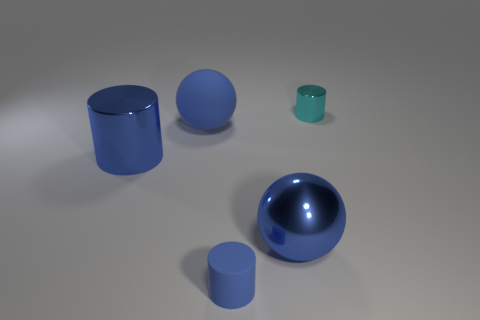Subtract all metal cylinders. How many cylinders are left? 1 Add 2 tiny yellow cylinders. How many objects exist? 7 Subtract all cylinders. How many objects are left? 2 Add 4 big shiny cylinders. How many big shiny cylinders are left? 5 Add 4 rubber objects. How many rubber objects exist? 6 Subtract 0 red cylinders. How many objects are left? 5 Subtract all metal things. Subtract all large metallic cylinders. How many objects are left? 1 